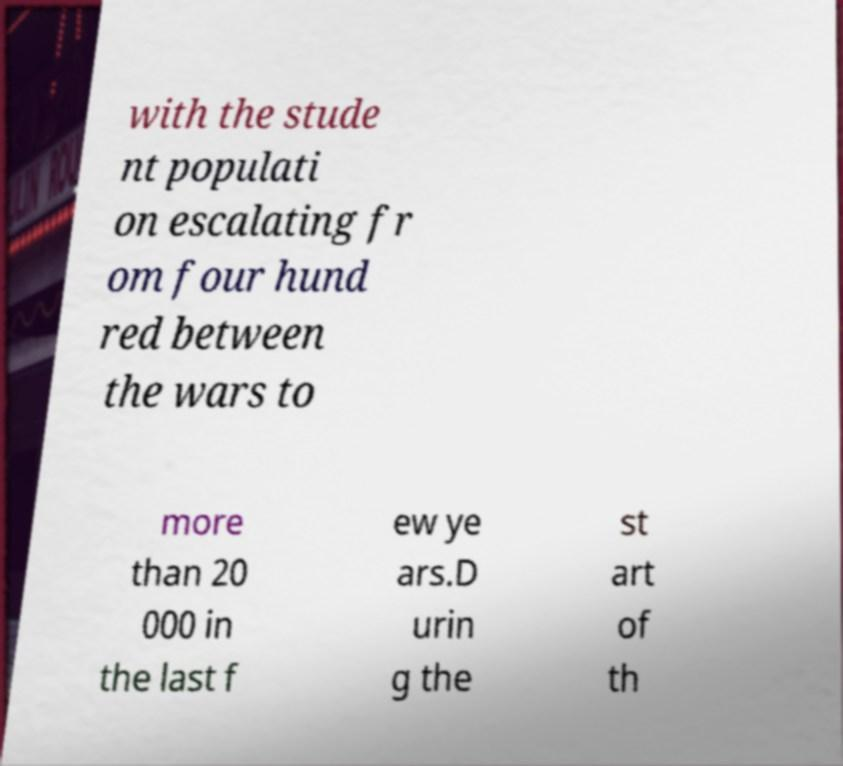Could you extract and type out the text from this image? with the stude nt populati on escalating fr om four hund red between the wars to more than 20 000 in the last f ew ye ars.D urin g the st art of th 